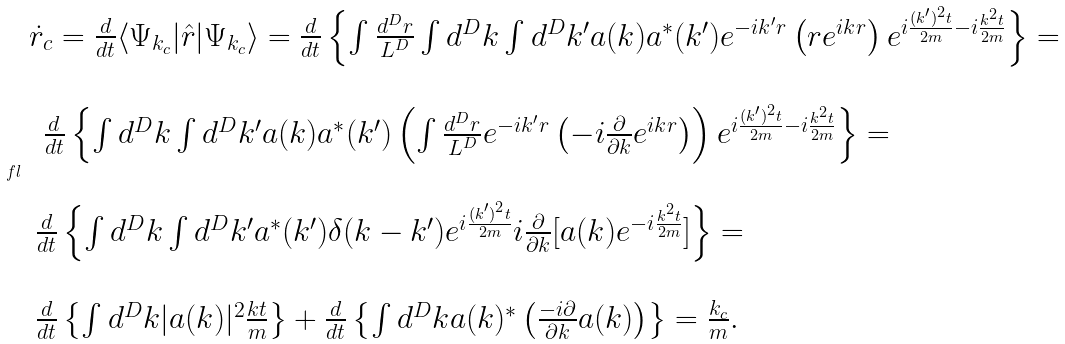Convert formula to latex. <formula><loc_0><loc_0><loc_500><loc_500>\ f l \begin{array} { l } \dot { r } _ { c } = \frac { d } { d t } \langle \Psi _ { k _ { c } } | \hat { r } | \Psi _ { k _ { c } } \rangle = \frac { d } { d t } \left \{ \int \frac { d ^ { D } { r } } { L ^ { D } } \int d ^ { D } { k } \int d ^ { D } { k ^ { \prime } } a ( { k } ) a ^ { * } ( { k ^ { \prime } } ) e ^ { - i { k ^ { \prime } r } } \left ( { r } e ^ { i { k r } } \right ) e ^ { i \frac { ( k ^ { \prime } ) ^ { 2 } t } { 2 m } - i \frac { k ^ { 2 } t } { 2 m } } \right \} = \\ \\ \, \ \frac { d } { d t } \left \{ \int d ^ { D } { k } \int d ^ { D } { k ^ { \prime } } a ( { k } ) a ^ { * } ( { k ^ { \prime } } ) \left ( \int \frac { d ^ { D } { r } } { L ^ { D } } e ^ { - i { k ^ { \prime } r } } \left ( - i \frac { \partial } { \partial k } e ^ { i { k r } } \right ) \right ) e ^ { i \frac { ( k ^ { \prime } ) ^ { 2 } t } { 2 m } - i \frac { k ^ { 2 } t } { 2 m } } \right \} = \\ \\ \, \frac { d } { d t } \left \{ \int d ^ { D } { k } \int d ^ { D } { k ^ { \prime } } a ^ { * } ( { k ^ { \prime } } ) \delta ( { k } - { k ^ { \prime } } ) e ^ { i \frac { ( k ^ { \prime } ) ^ { 2 } t } { 2 m } } i \frac { \partial } { \partial { k } } [ a ( { k } ) e ^ { - i \frac { k ^ { 2 } t } { 2 m } } ] \right \} = \\ \\ \, \frac { d } { d t } \left \{ \int d ^ { D } { k } | a ( { k } ) | ^ { 2 } \frac { { k } t } { m } \right \} + \frac { d } { d t } \left \{ \int d ^ { D } { k } a ( { k } ) ^ { * } \left ( \frac { - i \partial } { \partial { k } } a ( { k } ) \right ) \right \} = \frac { k _ { c } } { m } . \end{array}</formula> 